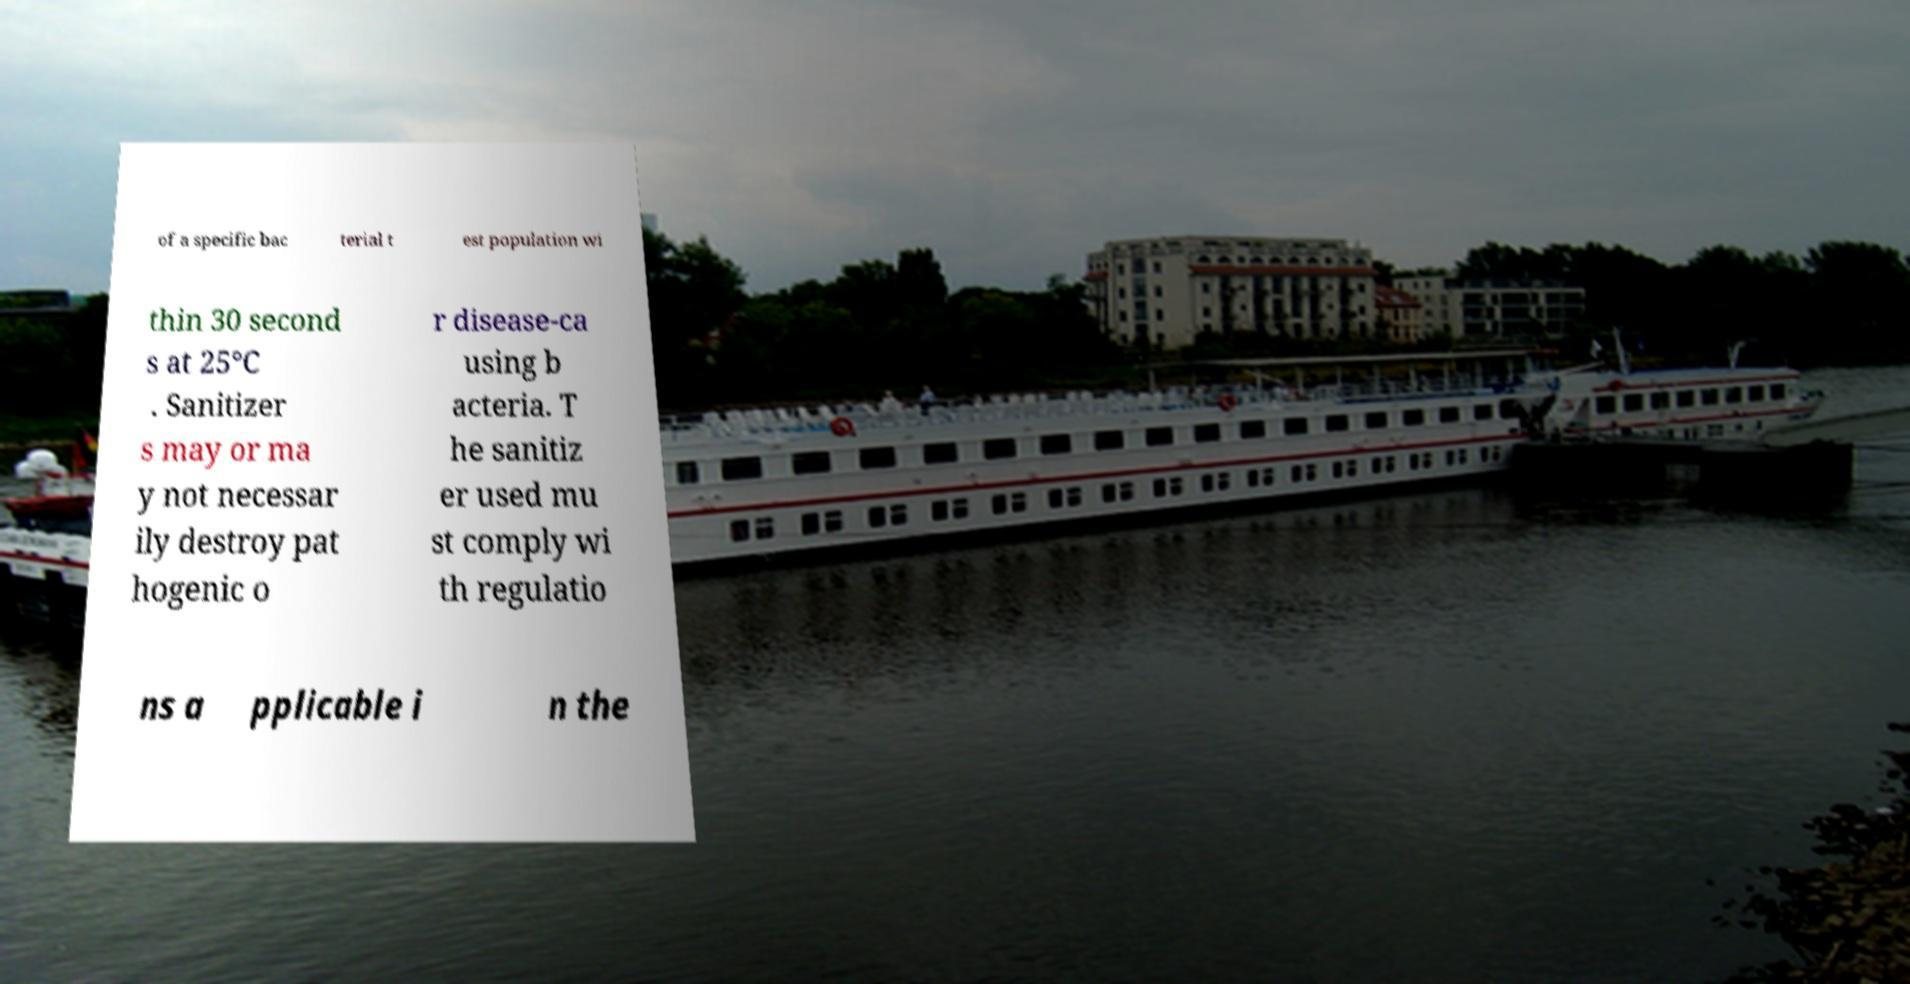I need the written content from this picture converted into text. Can you do that? of a specific bac terial t est population wi thin 30 second s at 25°C . Sanitizer s may or ma y not necessar ily destroy pat hogenic o r disease-ca using b acteria. T he sanitiz er used mu st comply wi th regulatio ns a pplicable i n the 